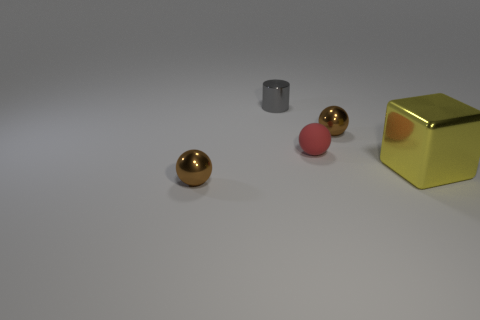Subtract all brown balls. How many balls are left? 1 Add 4 big cyan objects. How many objects exist? 9 Subtract all brown balls. How many balls are left? 1 Subtract 1 spheres. How many spheres are left? 2 Subtract all purple cylinders. How many brown balls are left? 2 Subtract 0 blue cubes. How many objects are left? 5 Subtract all balls. How many objects are left? 2 Subtract all cyan blocks. Subtract all green spheres. How many blocks are left? 1 Subtract all purple objects. Subtract all big yellow objects. How many objects are left? 4 Add 4 red things. How many red things are left? 5 